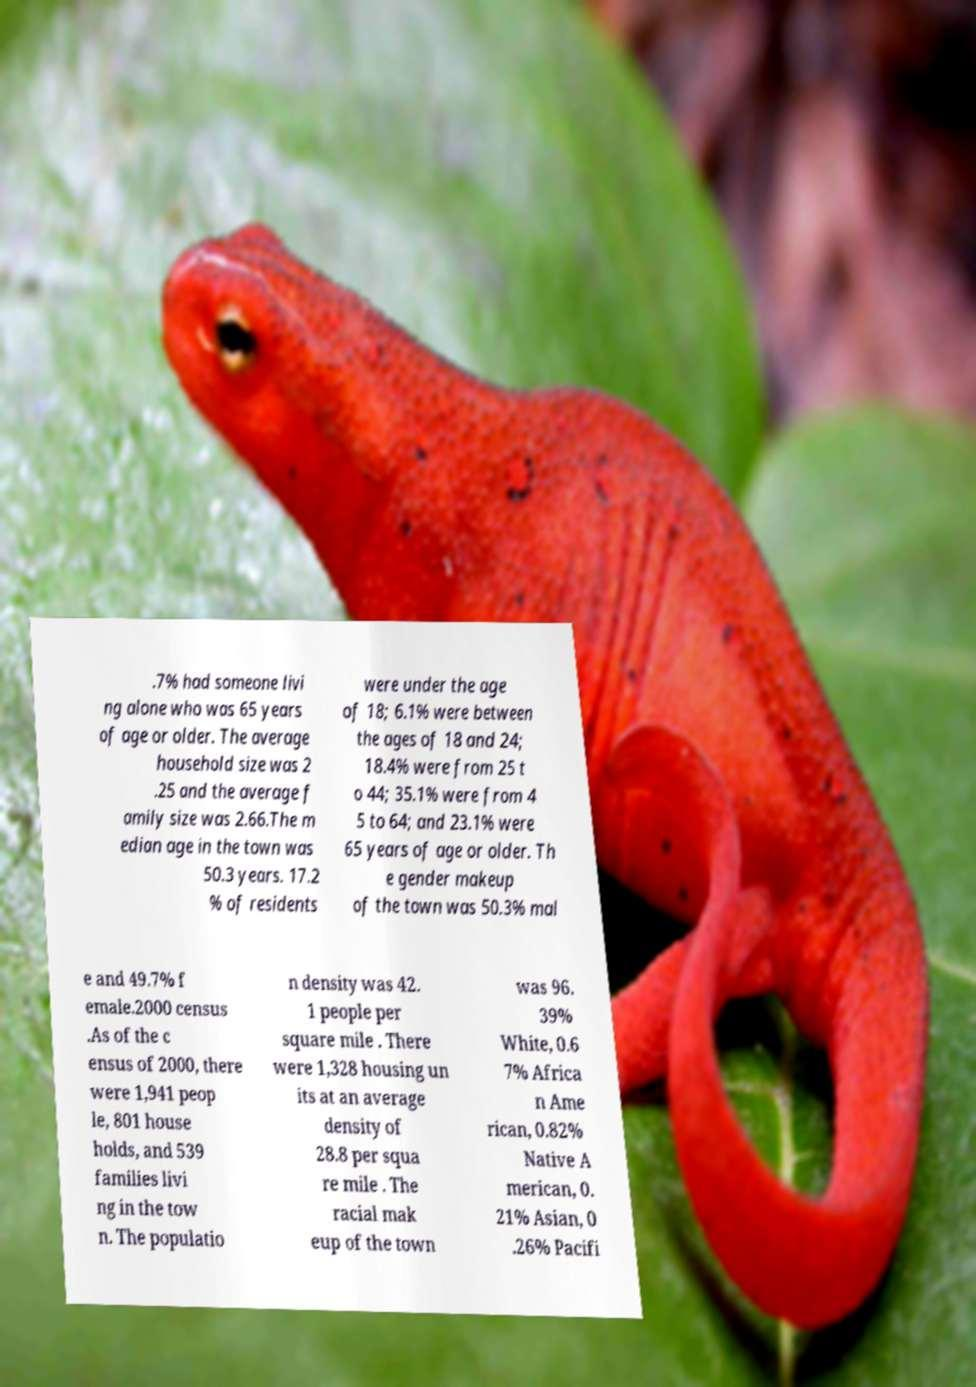Could you extract and type out the text from this image? .7% had someone livi ng alone who was 65 years of age or older. The average household size was 2 .25 and the average f amily size was 2.66.The m edian age in the town was 50.3 years. 17.2 % of residents were under the age of 18; 6.1% were between the ages of 18 and 24; 18.4% were from 25 t o 44; 35.1% were from 4 5 to 64; and 23.1% were 65 years of age or older. Th e gender makeup of the town was 50.3% mal e and 49.7% f emale.2000 census .As of the c ensus of 2000, there were 1,941 peop le, 801 house holds, and 539 families livi ng in the tow n. The populatio n density was 42. 1 people per square mile . There were 1,328 housing un its at an average density of 28.8 per squa re mile . The racial mak eup of the town was 96. 39% White, 0.6 7% Africa n Ame rican, 0.82% Native A merican, 0. 21% Asian, 0 .26% Pacifi 